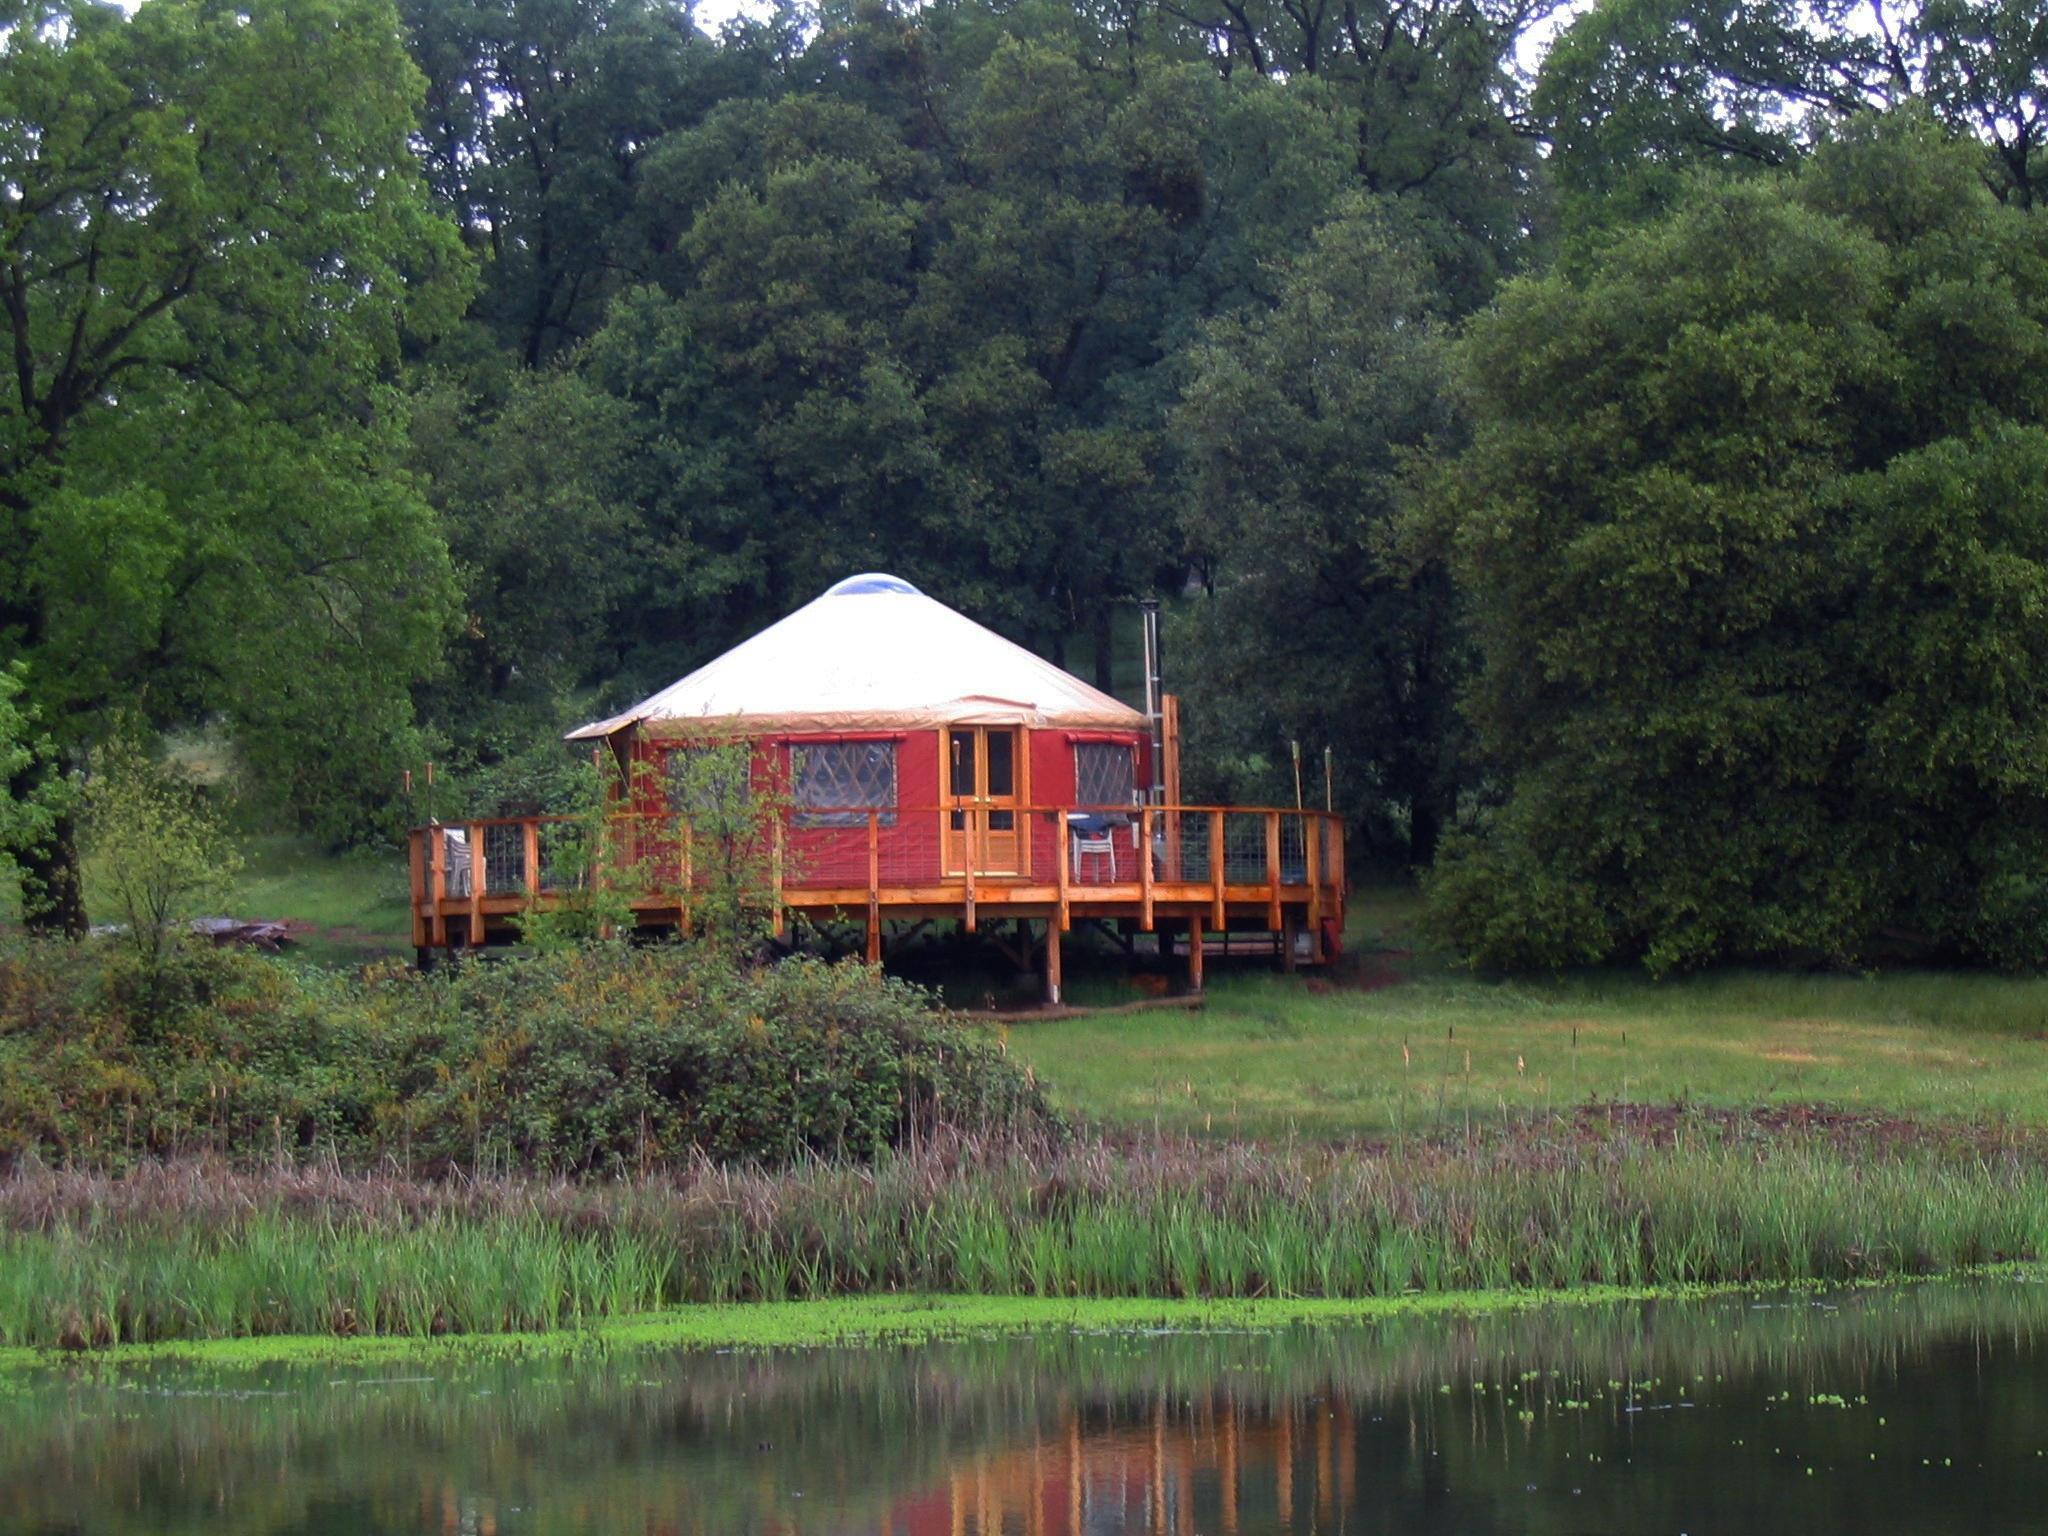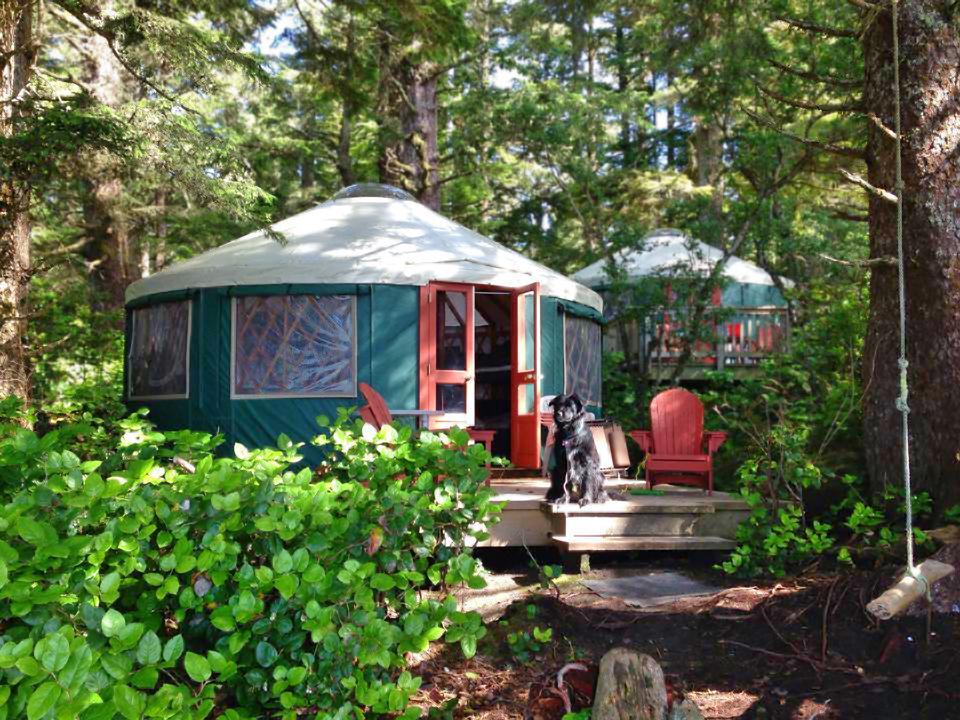The first image is the image on the left, the second image is the image on the right. Evaluate the accuracy of this statement regarding the images: "One image contains two round structures wrapped in greenish-blue material and situated among trees.". Is it true? Answer yes or no. Yes. 